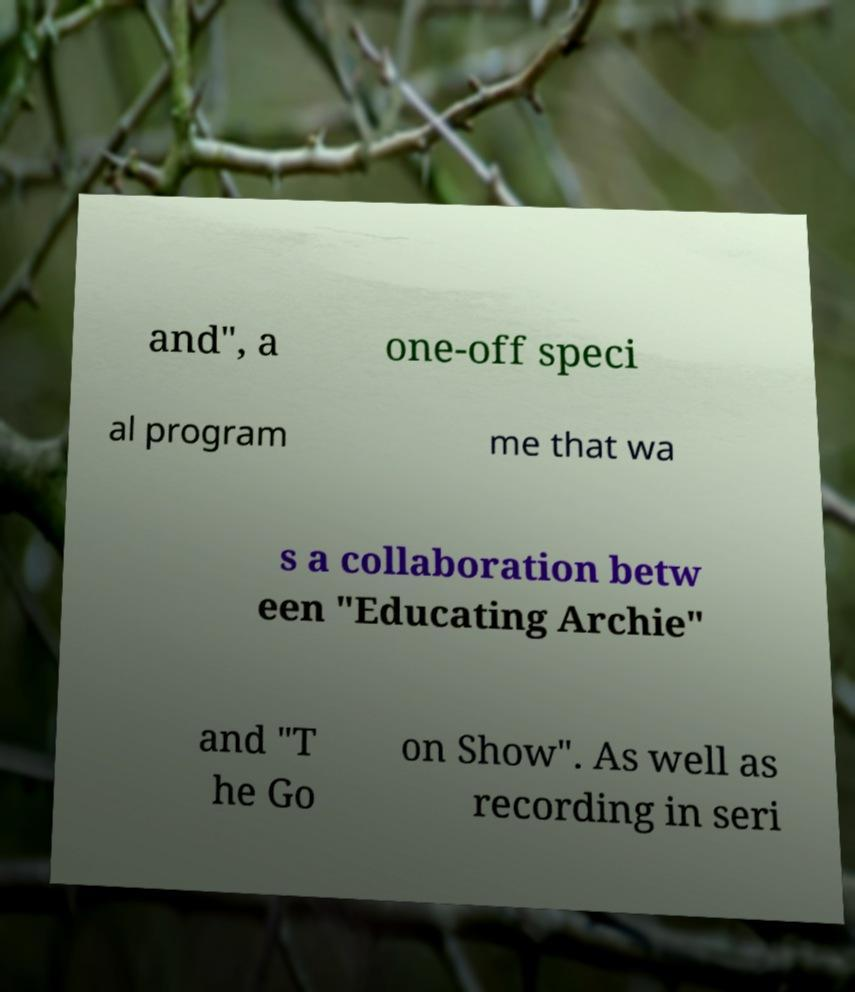There's text embedded in this image that I need extracted. Can you transcribe it verbatim? and", a one-off speci al program me that wa s a collaboration betw een "Educating Archie" and "T he Go on Show". As well as recording in seri 